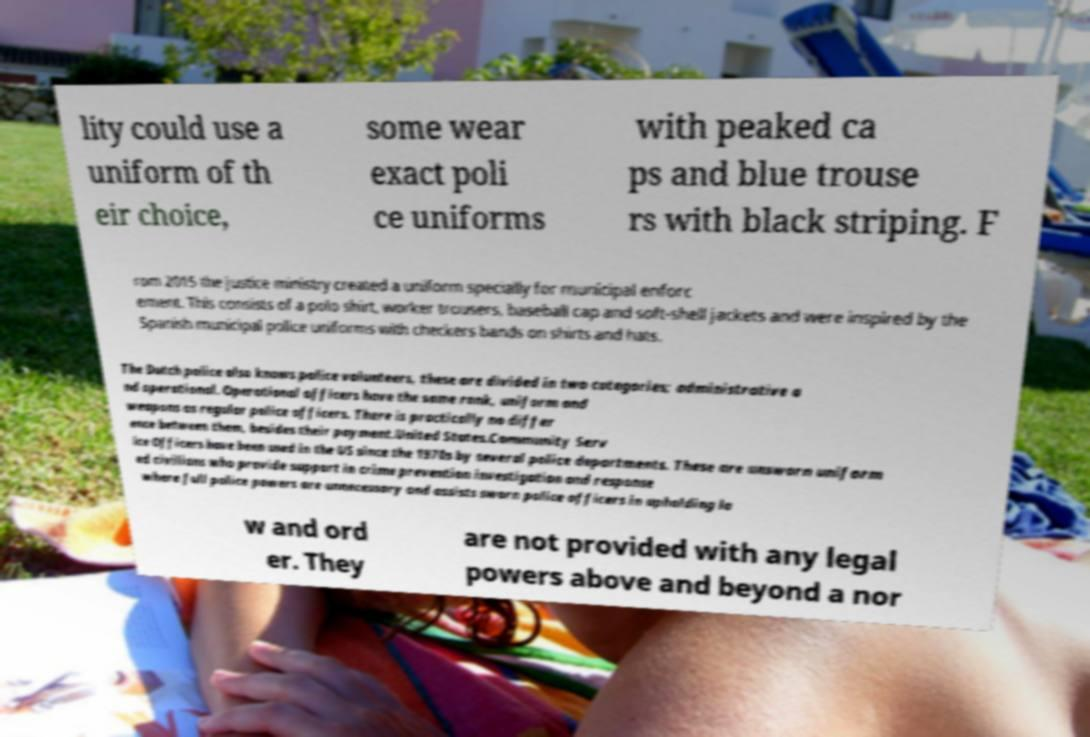Could you assist in decoding the text presented in this image and type it out clearly? lity could use a uniform of th eir choice, some wear exact poli ce uniforms with peaked ca ps and blue trouse rs with black striping. F rom 2015 the justice ministry created a uniform specially for municipal enforc ement. This consists of a polo shirt, worker trousers, baseball cap and soft-shell jackets and were inspired by the Spanish municipal police uniforms with checkers bands on shirts and hats. The Dutch police also knows police volunteers, these are divided in two categories; administrative a nd operational. Operational officers have the same rank, uniform and weapons as regular police officers. There is practically no differ ence between them, besides their payment.United States.Community Serv ice Officers have been used in the US since the 1970s by several police departments. These are unsworn uniform ed civilians who provide support in crime prevention investigation and response where full police powers are unnecessary and assists sworn police officers in upholding la w and ord er. They are not provided with any legal powers above and beyond a nor 